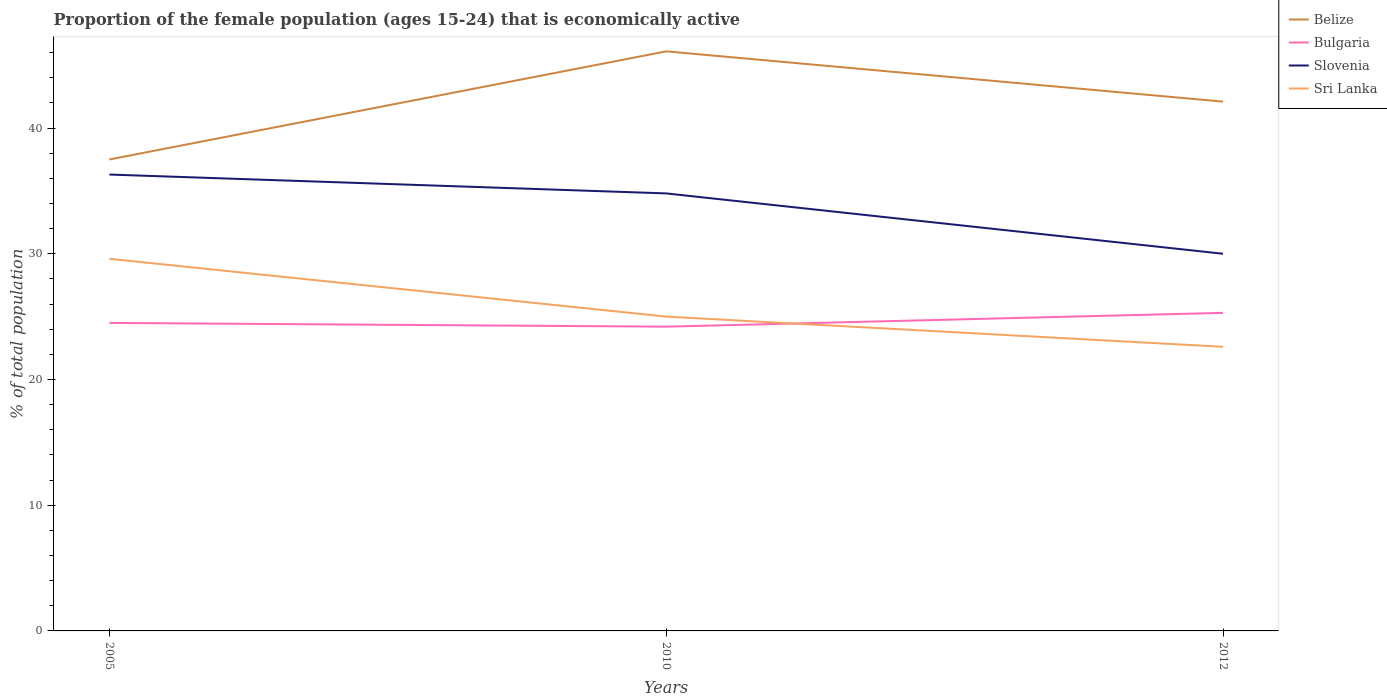Does the line corresponding to Belize intersect with the line corresponding to Bulgaria?
Keep it short and to the point. No. Is the number of lines equal to the number of legend labels?
Provide a short and direct response. Yes. Across all years, what is the maximum proportion of the female population that is economically active in Bulgaria?
Provide a short and direct response. 24.2. In which year was the proportion of the female population that is economically active in Bulgaria maximum?
Keep it short and to the point. 2010. What is the total proportion of the female population that is economically active in Belize in the graph?
Your answer should be compact. -4.6. What is the difference between the highest and the second highest proportion of the female population that is economically active in Bulgaria?
Your response must be concise. 1.1. What is the difference between the highest and the lowest proportion of the female population that is economically active in Belize?
Make the answer very short. 2. Is the proportion of the female population that is economically active in Belize strictly greater than the proportion of the female population that is economically active in Bulgaria over the years?
Offer a very short reply. No. Does the graph contain any zero values?
Offer a terse response. No. Does the graph contain grids?
Your response must be concise. No. Where does the legend appear in the graph?
Provide a succinct answer. Top right. How many legend labels are there?
Your response must be concise. 4. What is the title of the graph?
Ensure brevity in your answer.  Proportion of the female population (ages 15-24) that is economically active. Does "Grenada" appear as one of the legend labels in the graph?
Keep it short and to the point. No. What is the label or title of the Y-axis?
Your answer should be compact. % of total population. What is the % of total population of Belize in 2005?
Give a very brief answer. 37.5. What is the % of total population of Bulgaria in 2005?
Offer a terse response. 24.5. What is the % of total population in Slovenia in 2005?
Make the answer very short. 36.3. What is the % of total population in Sri Lanka in 2005?
Offer a terse response. 29.6. What is the % of total population in Belize in 2010?
Provide a short and direct response. 46.1. What is the % of total population of Bulgaria in 2010?
Ensure brevity in your answer.  24.2. What is the % of total population in Slovenia in 2010?
Provide a short and direct response. 34.8. What is the % of total population of Belize in 2012?
Give a very brief answer. 42.1. What is the % of total population of Bulgaria in 2012?
Your response must be concise. 25.3. What is the % of total population in Slovenia in 2012?
Make the answer very short. 30. What is the % of total population of Sri Lanka in 2012?
Make the answer very short. 22.6. Across all years, what is the maximum % of total population in Belize?
Provide a succinct answer. 46.1. Across all years, what is the maximum % of total population of Bulgaria?
Offer a very short reply. 25.3. Across all years, what is the maximum % of total population of Slovenia?
Give a very brief answer. 36.3. Across all years, what is the maximum % of total population of Sri Lanka?
Offer a terse response. 29.6. Across all years, what is the minimum % of total population of Belize?
Give a very brief answer. 37.5. Across all years, what is the minimum % of total population in Bulgaria?
Provide a succinct answer. 24.2. Across all years, what is the minimum % of total population of Sri Lanka?
Your response must be concise. 22.6. What is the total % of total population of Belize in the graph?
Provide a short and direct response. 125.7. What is the total % of total population in Bulgaria in the graph?
Your answer should be very brief. 74. What is the total % of total population in Slovenia in the graph?
Provide a short and direct response. 101.1. What is the total % of total population in Sri Lanka in the graph?
Provide a short and direct response. 77.2. What is the difference between the % of total population in Belize in 2005 and that in 2010?
Keep it short and to the point. -8.6. What is the difference between the % of total population in Bulgaria in 2005 and that in 2010?
Offer a terse response. 0.3. What is the difference between the % of total population of Slovenia in 2005 and that in 2010?
Make the answer very short. 1.5. What is the difference between the % of total population of Sri Lanka in 2005 and that in 2010?
Your response must be concise. 4.6. What is the difference between the % of total population in Bulgaria in 2005 and that in 2012?
Keep it short and to the point. -0.8. What is the difference between the % of total population in Belize in 2010 and that in 2012?
Provide a succinct answer. 4. What is the difference between the % of total population in Slovenia in 2010 and that in 2012?
Your answer should be compact. 4.8. What is the difference between the % of total population in Sri Lanka in 2010 and that in 2012?
Offer a terse response. 2.4. What is the difference between the % of total population in Belize in 2005 and the % of total population in Slovenia in 2010?
Make the answer very short. 2.7. What is the difference between the % of total population in Bulgaria in 2005 and the % of total population in Sri Lanka in 2010?
Your response must be concise. -0.5. What is the difference between the % of total population in Slovenia in 2005 and the % of total population in Sri Lanka in 2010?
Ensure brevity in your answer.  11.3. What is the difference between the % of total population of Belize in 2005 and the % of total population of Slovenia in 2012?
Make the answer very short. 7.5. What is the difference between the % of total population of Belize in 2010 and the % of total population of Bulgaria in 2012?
Offer a terse response. 20.8. What is the difference between the % of total population of Belize in 2010 and the % of total population of Slovenia in 2012?
Your answer should be compact. 16.1. What is the difference between the % of total population of Belize in 2010 and the % of total population of Sri Lanka in 2012?
Offer a terse response. 23.5. What is the difference between the % of total population in Bulgaria in 2010 and the % of total population in Slovenia in 2012?
Make the answer very short. -5.8. What is the average % of total population of Belize per year?
Offer a very short reply. 41.9. What is the average % of total population in Bulgaria per year?
Offer a very short reply. 24.67. What is the average % of total population of Slovenia per year?
Your answer should be very brief. 33.7. What is the average % of total population of Sri Lanka per year?
Your answer should be compact. 25.73. In the year 2005, what is the difference between the % of total population of Belize and % of total population of Slovenia?
Your answer should be very brief. 1.2. In the year 2005, what is the difference between the % of total population in Belize and % of total population in Sri Lanka?
Offer a very short reply. 7.9. In the year 2010, what is the difference between the % of total population of Belize and % of total population of Bulgaria?
Your answer should be very brief. 21.9. In the year 2010, what is the difference between the % of total population in Belize and % of total population in Slovenia?
Your answer should be very brief. 11.3. In the year 2010, what is the difference between the % of total population in Belize and % of total population in Sri Lanka?
Ensure brevity in your answer.  21.1. In the year 2010, what is the difference between the % of total population in Slovenia and % of total population in Sri Lanka?
Offer a terse response. 9.8. In the year 2012, what is the difference between the % of total population in Belize and % of total population in Bulgaria?
Your answer should be very brief. 16.8. In the year 2012, what is the difference between the % of total population in Belize and % of total population in Sri Lanka?
Provide a short and direct response. 19.5. In the year 2012, what is the difference between the % of total population of Bulgaria and % of total population of Slovenia?
Make the answer very short. -4.7. In the year 2012, what is the difference between the % of total population in Slovenia and % of total population in Sri Lanka?
Offer a very short reply. 7.4. What is the ratio of the % of total population in Belize in 2005 to that in 2010?
Offer a very short reply. 0.81. What is the ratio of the % of total population of Bulgaria in 2005 to that in 2010?
Your answer should be compact. 1.01. What is the ratio of the % of total population of Slovenia in 2005 to that in 2010?
Your response must be concise. 1.04. What is the ratio of the % of total population of Sri Lanka in 2005 to that in 2010?
Provide a succinct answer. 1.18. What is the ratio of the % of total population in Belize in 2005 to that in 2012?
Keep it short and to the point. 0.89. What is the ratio of the % of total population in Bulgaria in 2005 to that in 2012?
Ensure brevity in your answer.  0.97. What is the ratio of the % of total population in Slovenia in 2005 to that in 2012?
Your response must be concise. 1.21. What is the ratio of the % of total population in Sri Lanka in 2005 to that in 2012?
Ensure brevity in your answer.  1.31. What is the ratio of the % of total population in Belize in 2010 to that in 2012?
Ensure brevity in your answer.  1.09. What is the ratio of the % of total population of Bulgaria in 2010 to that in 2012?
Provide a succinct answer. 0.96. What is the ratio of the % of total population in Slovenia in 2010 to that in 2012?
Provide a succinct answer. 1.16. What is the ratio of the % of total population in Sri Lanka in 2010 to that in 2012?
Provide a short and direct response. 1.11. What is the difference between the highest and the second highest % of total population of Slovenia?
Provide a succinct answer. 1.5. What is the difference between the highest and the second highest % of total population of Sri Lanka?
Offer a terse response. 4.6. What is the difference between the highest and the lowest % of total population in Belize?
Your response must be concise. 8.6. What is the difference between the highest and the lowest % of total population of Bulgaria?
Ensure brevity in your answer.  1.1. What is the difference between the highest and the lowest % of total population in Sri Lanka?
Your response must be concise. 7. 